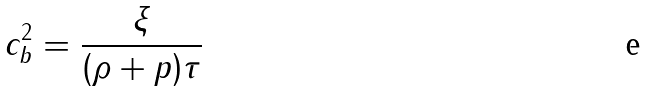<formula> <loc_0><loc_0><loc_500><loc_500>c _ { b } ^ { 2 } = \frac { \xi } { ( \rho + p ) \tau }</formula> 